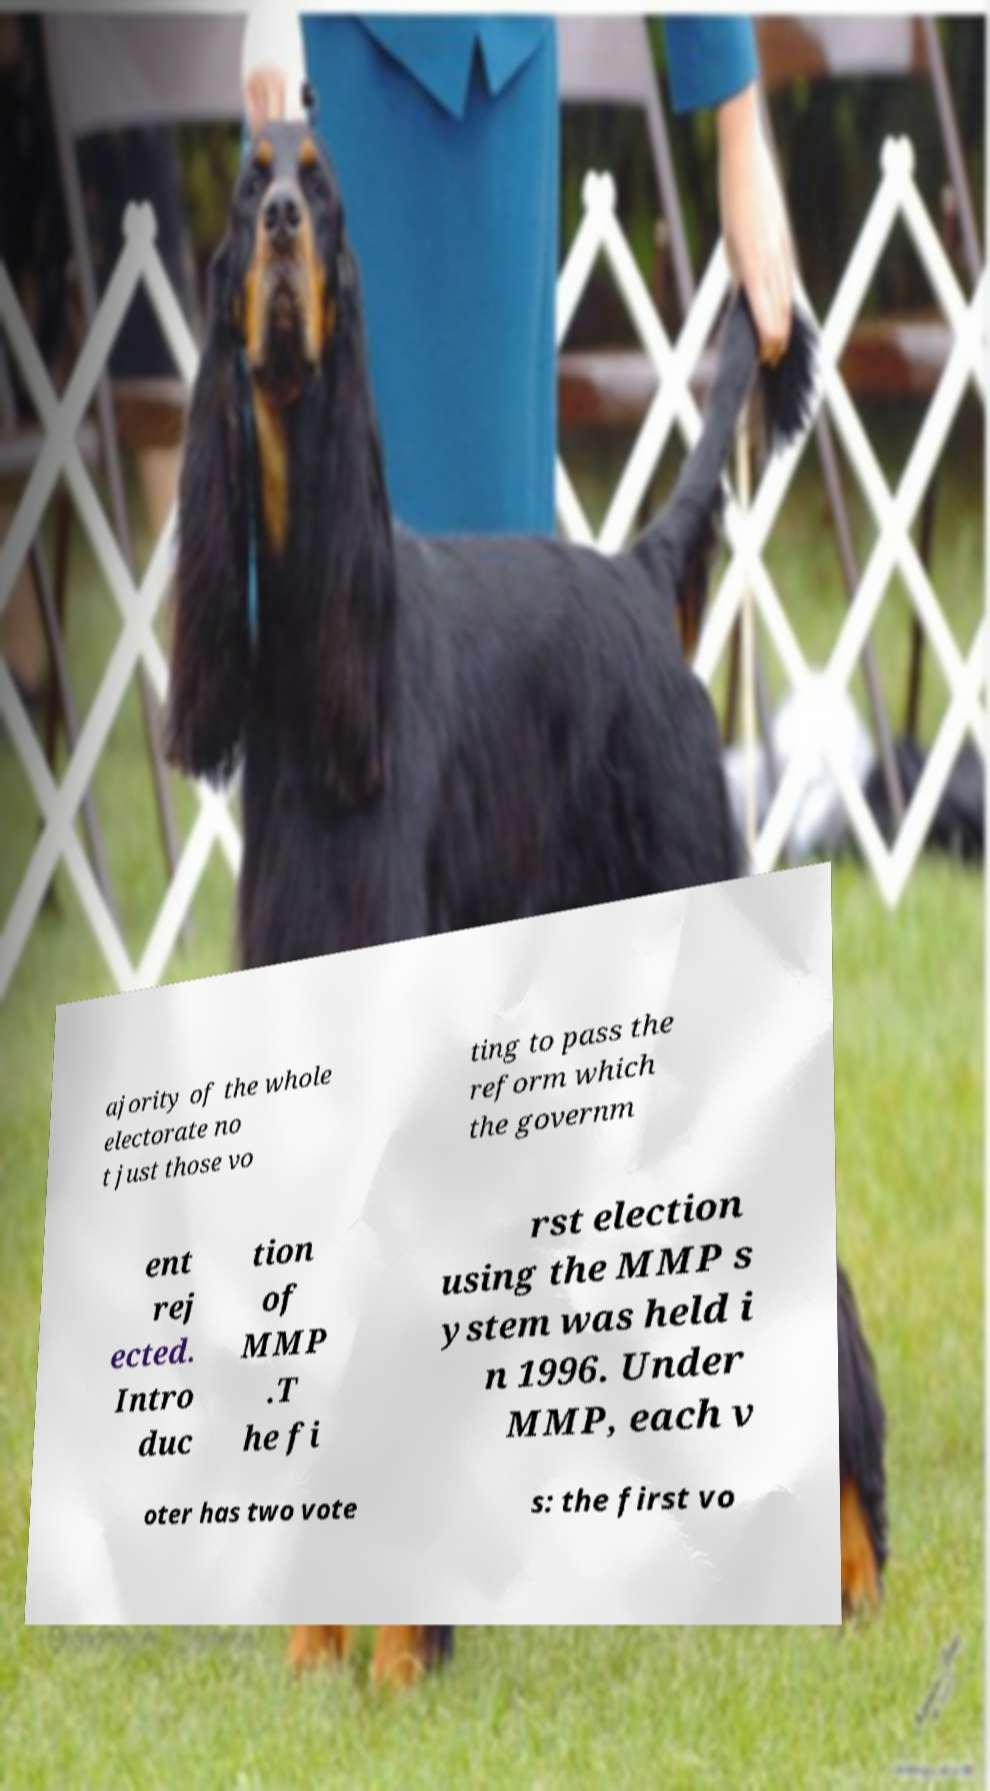Can you read and provide the text displayed in the image?This photo seems to have some interesting text. Can you extract and type it out for me? ajority of the whole electorate no t just those vo ting to pass the reform which the governm ent rej ected. Intro duc tion of MMP .T he fi rst election using the MMP s ystem was held i n 1996. Under MMP, each v oter has two vote s: the first vo 